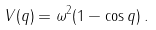<formula> <loc_0><loc_0><loc_500><loc_500>V ( q ) = \omega ^ { 2 } ( 1 - \cos q ) \, .</formula> 